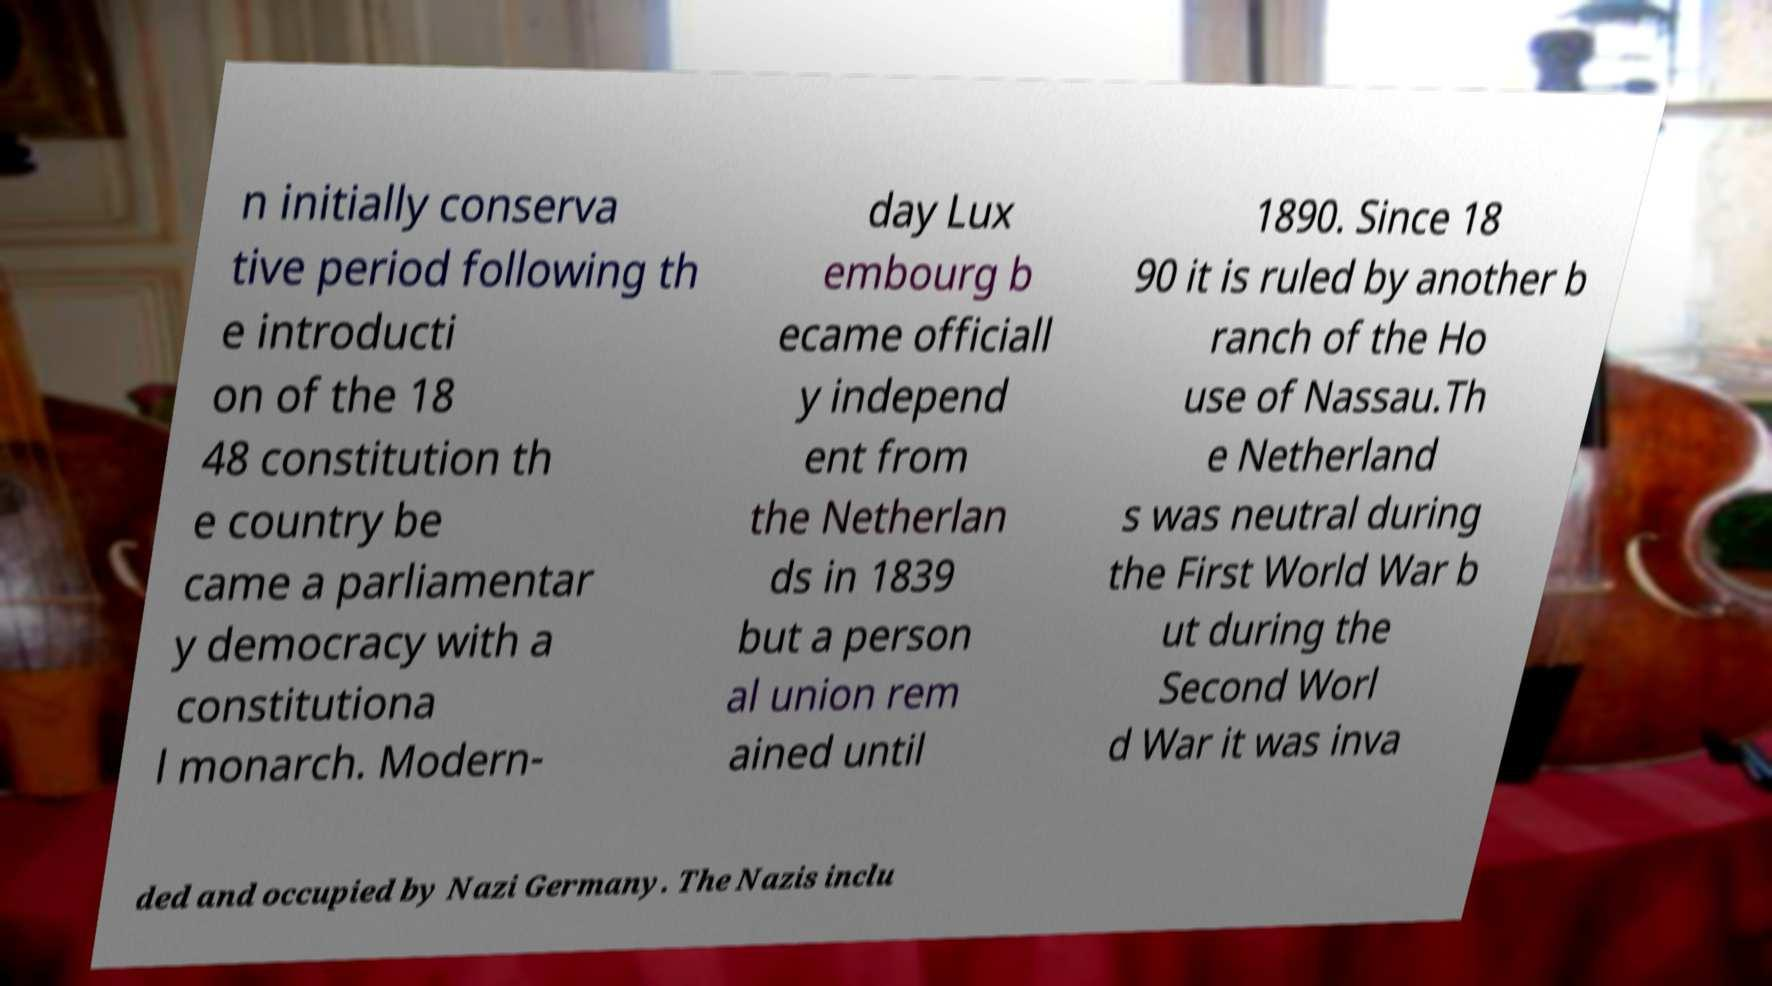For documentation purposes, I need the text within this image transcribed. Could you provide that? n initially conserva tive period following th e introducti on of the 18 48 constitution th e country be came a parliamentar y democracy with a constitutiona l monarch. Modern- day Lux embourg b ecame officiall y independ ent from the Netherlan ds in 1839 but a person al union rem ained until 1890. Since 18 90 it is ruled by another b ranch of the Ho use of Nassau.Th e Netherland s was neutral during the First World War b ut during the Second Worl d War it was inva ded and occupied by Nazi Germany. The Nazis inclu 